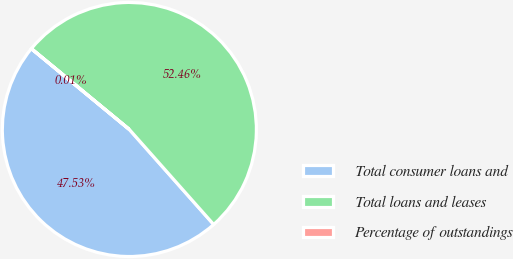Convert chart. <chart><loc_0><loc_0><loc_500><loc_500><pie_chart><fcel>Total consumer loans and<fcel>Total loans and leases<fcel>Percentage of outstandings<nl><fcel>47.53%<fcel>52.47%<fcel>0.01%<nl></chart> 